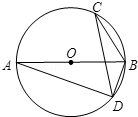Question: In circle O, with diameter AB, points C and D lie on the circumference. If angle C measures 'x' degrees, what is the measure of angle ABD in terms of 'x'? To determine the measure of angle ABD in the circle diagram where AB is a diameter and points C and D are on the circumference, we begin by noting that angle ADB is 90 degrees because angle inscribed in a semicircle is a right angle. Angle A at the center equates to angle C by the property of inscribed angles, given at 'x' degrees. This infers that angle ABD is the difference between 90 degrees and angle A, thus being 90 - x degrees. However, it is notable that the exact numerical match for this calculation was absent in the provided choices, indicating a potential error or oversight in the available options. 